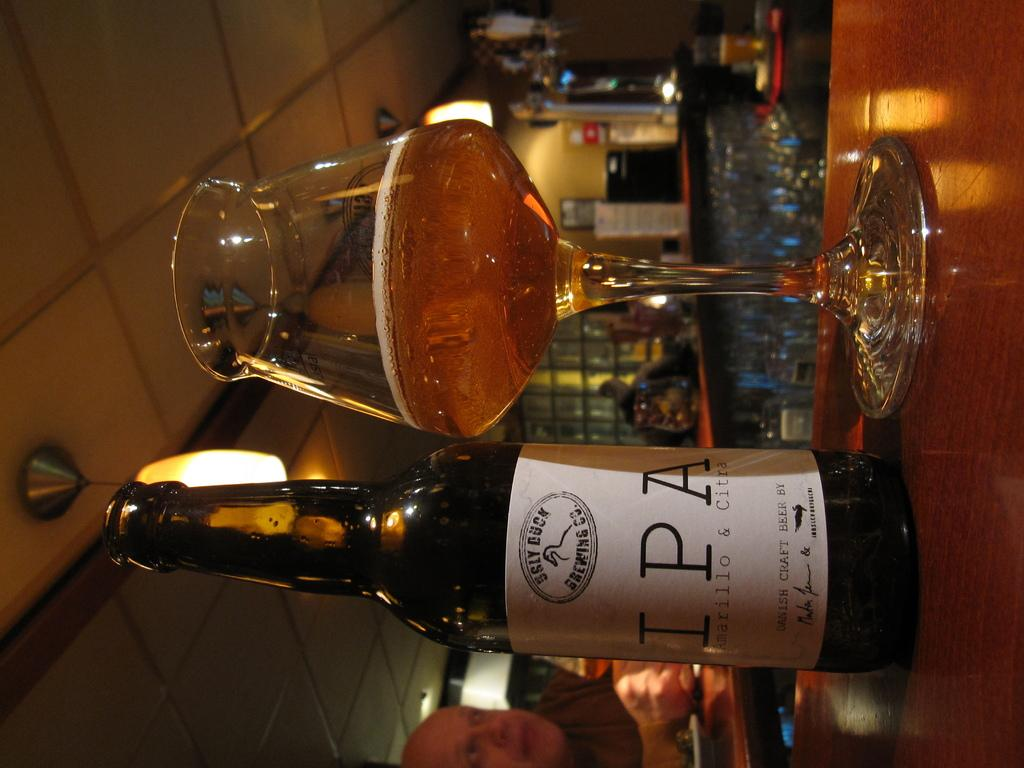<image>
Relay a brief, clear account of the picture shown. A bottle of Sly Duck Brewing Company beer is next to a partially filled glass. 